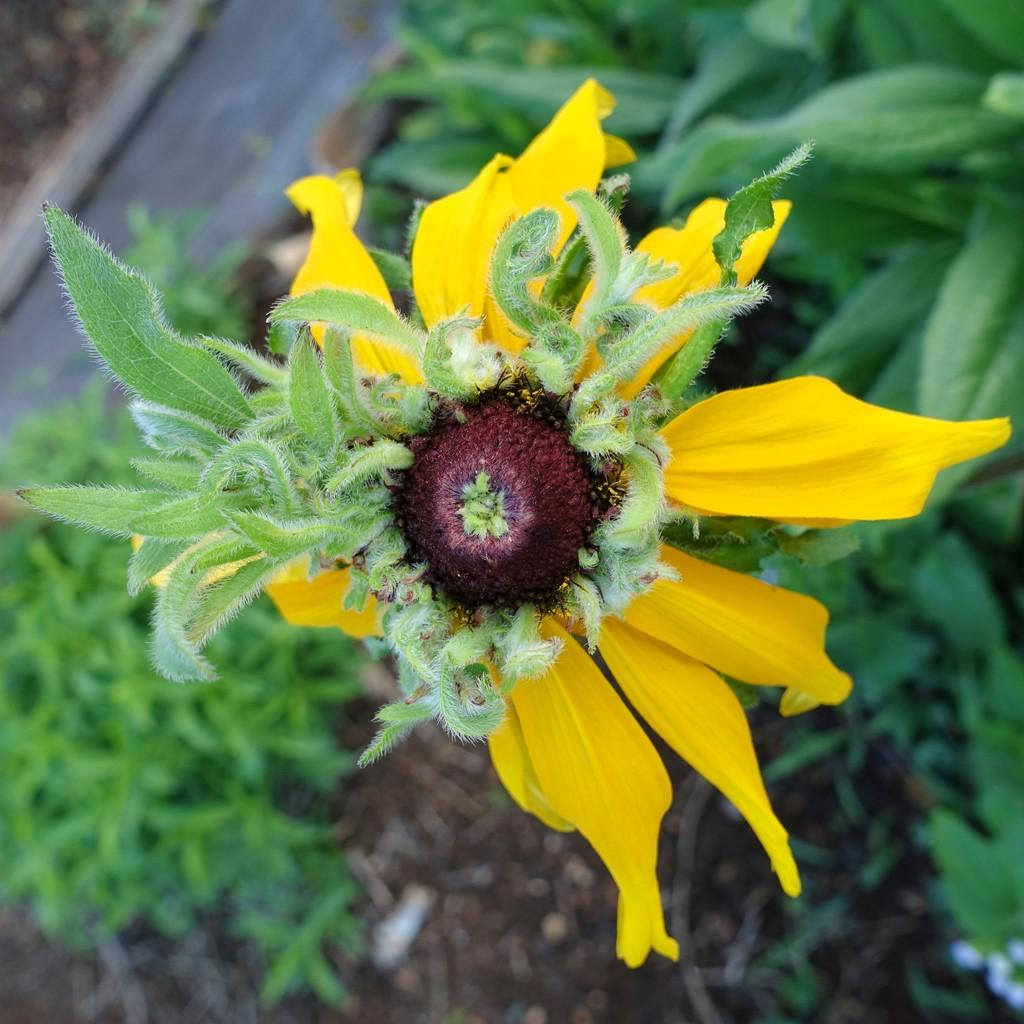What is the main subject of the image? There is a yellow color flower in the center of the image. What can be seen in the background of the image? There are leaves and grass visible in the background of the image. What time does the clock show in the image? There is no clock present in the image. What type of yarn is being used to create the flower in the image? The image does not depict a flower made of yarn; it is a real yellow flower. 